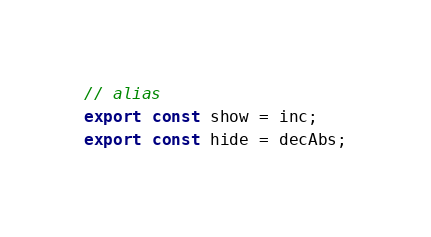Convert code to text. <code><loc_0><loc_0><loc_500><loc_500><_TypeScript_>
// alias
export const show = inc;
export const hide = decAbs;
</code> 